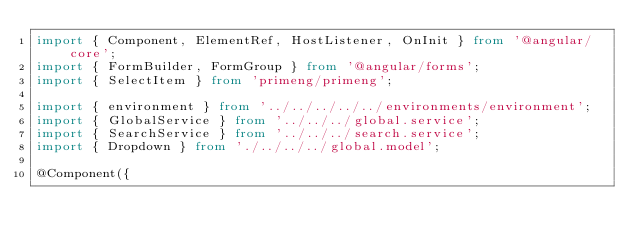<code> <loc_0><loc_0><loc_500><loc_500><_TypeScript_>import { Component, ElementRef, HostListener, OnInit } from '@angular/core';
import { FormBuilder, FormGroup } from '@angular/forms';
import { SelectItem } from 'primeng/primeng';

import { environment } from '../../../../../environments/environment';
import { GlobalService } from '../../../global.service';
import { SearchService } from '../../../search.service';
import { Dropdown } from './../../../global.model';

@Component({</code> 